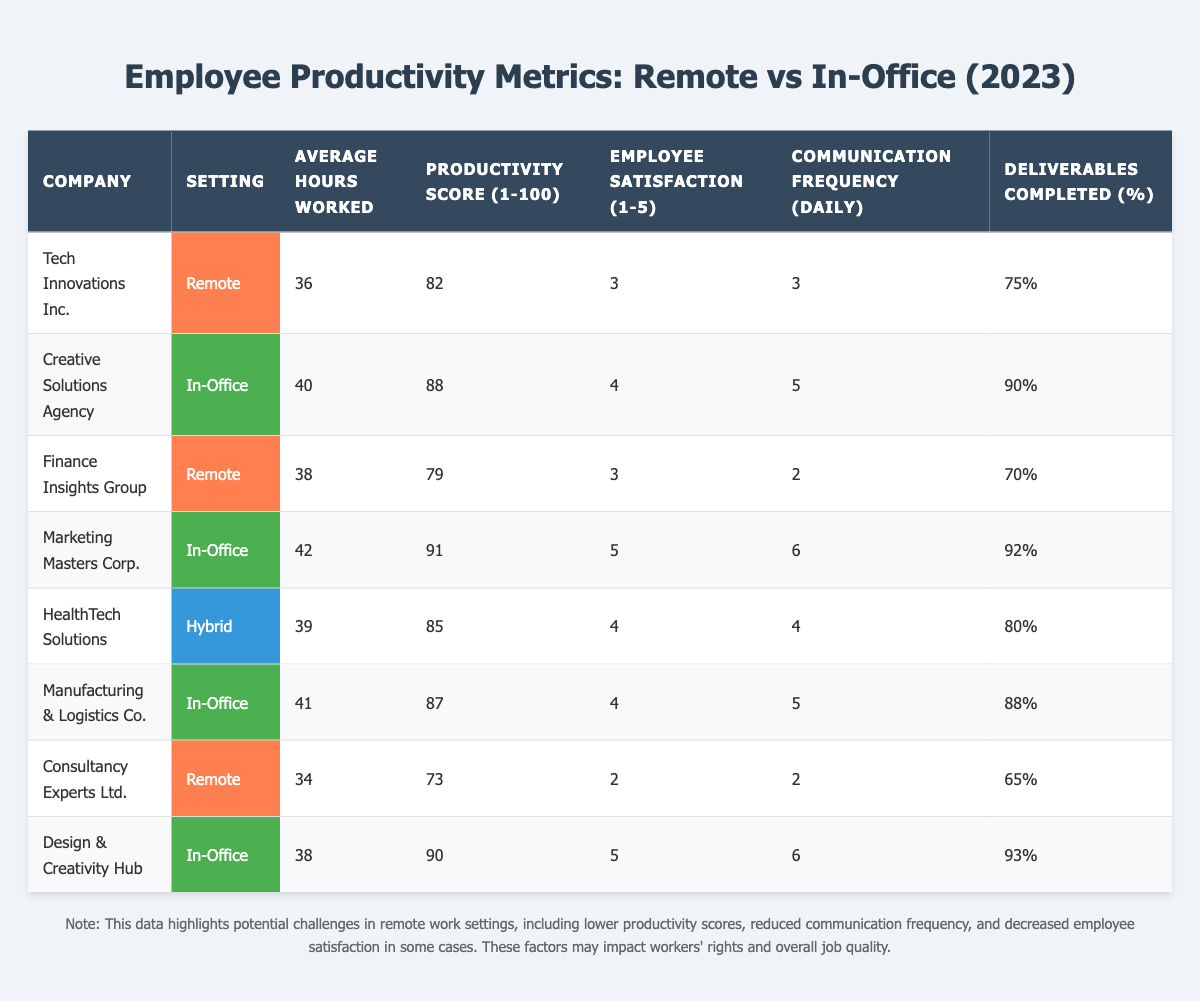What's the productivity score for Tech Innovations Inc.? The table lists Tech Innovations Inc. under the remote setting, where the productivity score is indicated as 82.
Answer: 82 Which company has the highest employee satisfaction? By examining the employee satisfaction ratings in the table, Marketing Masters Corp. and Design & Creativity Hub both have a score of 5, which is the highest among all companies.
Answer: Marketing Masters Corp. and Design & Creativity Hub How many average hours do employees at Finance Insights Group work? The table shows Finance Insights Group in the remote setting with an average of 38 hours worked.
Answer: 38 What is the average productivity score for companies in the remote setting? The productivity scores for remote companies are 82 (Tech Innovations Inc.), 79 (Finance Insights Group), and 73 (Consultancy Experts Ltd.). The average is calculated as (82 + 79 + 73) / 3 = 78.
Answer: 78 Is it true that employees in the in-office setting at Manufacturing & Logistics Co. complete more deliverables than employees in the remote setting at Consultancy Experts Ltd.? The deliverables completed for Manufacturing & Logistics Co. is 88%, and for Consultancy Experts Ltd. it is 65%. Since 88% is greater than 65%, the statement is true.
Answer: Yes Which setting has a higher average for employee satisfaction across the companies? The average employee satisfaction for in-office companies is (4 + 5 + 4 + 5) / 4 = 4.5, while for remote companies it is (3 + 3 + 2) / 3 = 2.67. Therefore, in-office has a higher average.
Answer: In-office What are the communication frequencies for the companies in remote settings? The communication frequencies for remote companies listed are 3 for Tech Innovations Inc., 2 for Finance Insights Group, and 2 for Consultancy Experts Ltd.
Answer: 3, 2, 2 Which company had the best productivity score and what was it? From the table, Marketing Masters Corp. has the highest productivity score of 91 among all listed companies.
Answer: 91 Calculate the difference in deliverables completed percentage between the best and worst remote companies. The best remote company, Tech Innovations Inc., completed 75%, while the worst, Consultancy Experts Ltd., completed 65%. The difference is 75% - 65% = 10%.
Answer: 10% How does the average hours worked for in-office settings compare against the remote settings? The average hours for in-office are (40 + 42 + 41 + 38) / 4 = 40.25, while for remote they are (36 + 38 + 34) / 3 = 36. The in-office average of 40.25 is higher than the remote average of 36.
Answer: In-office is higher 